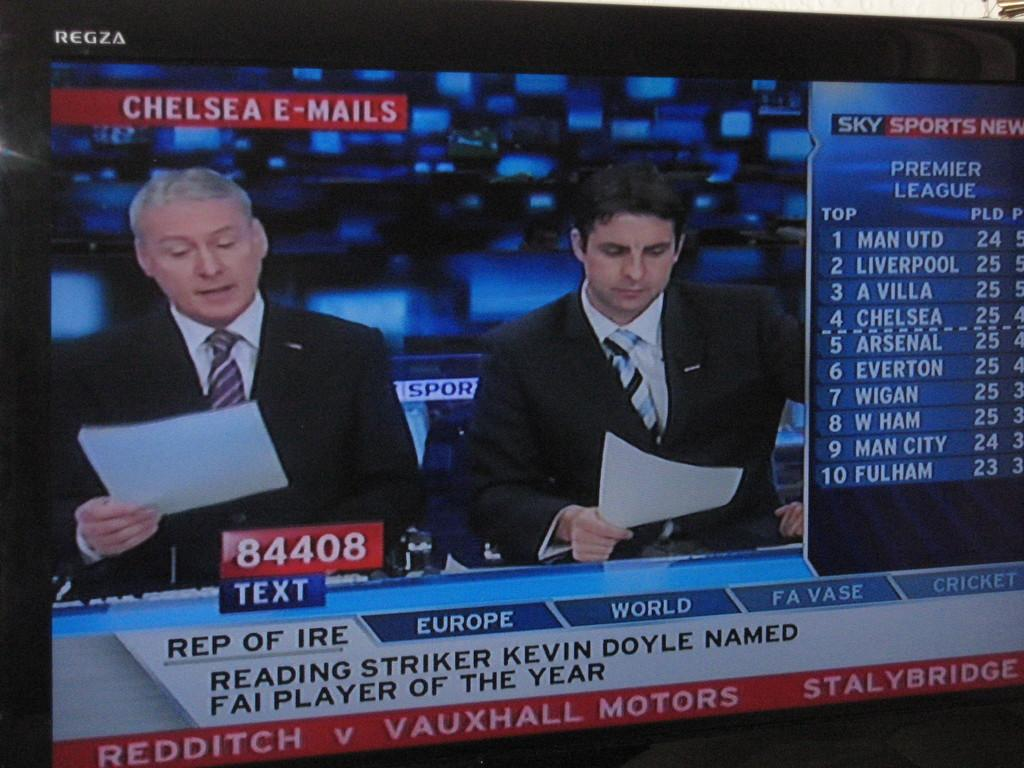<image>
Summarize the visual content of the image. A television screen is displaying sports announcers, who are both looking at papers and have sports stats to the side. 